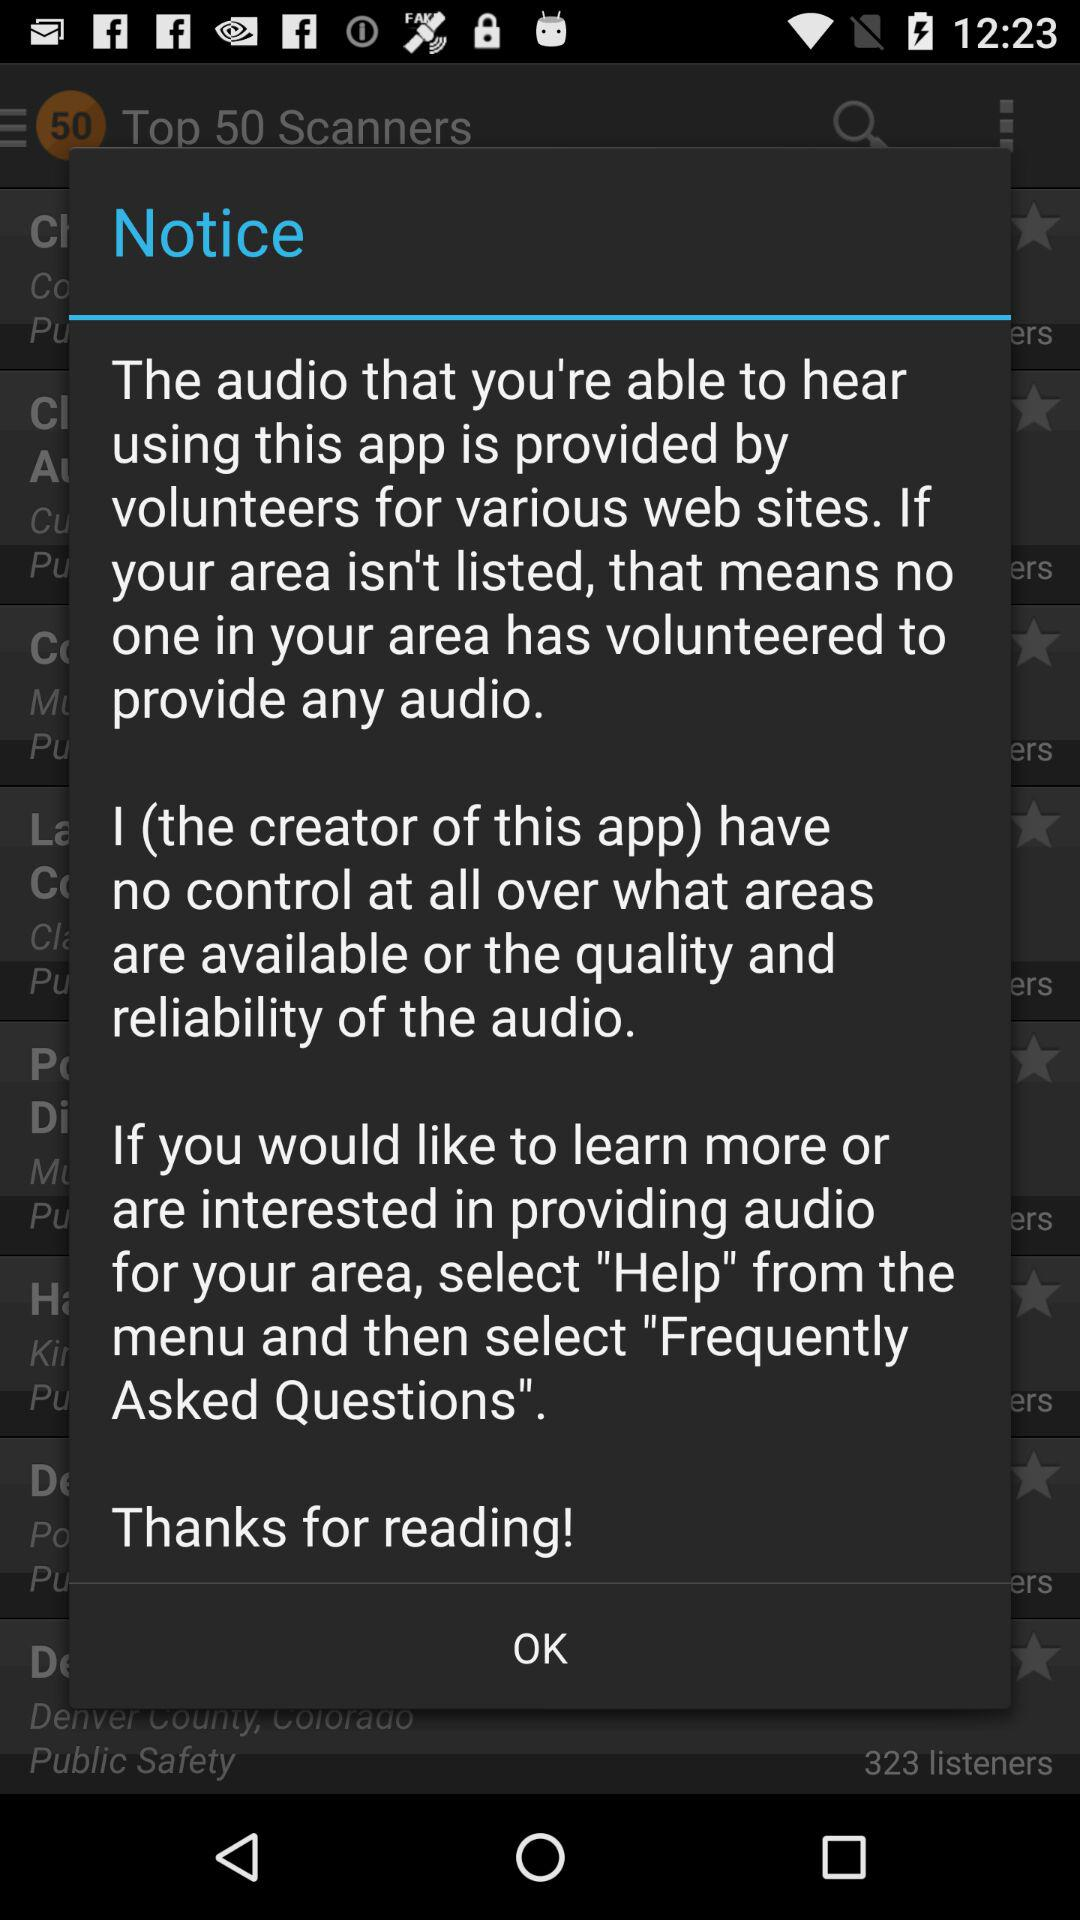How many sentences does the notice contain?
Answer the question using a single word or phrase. 4 